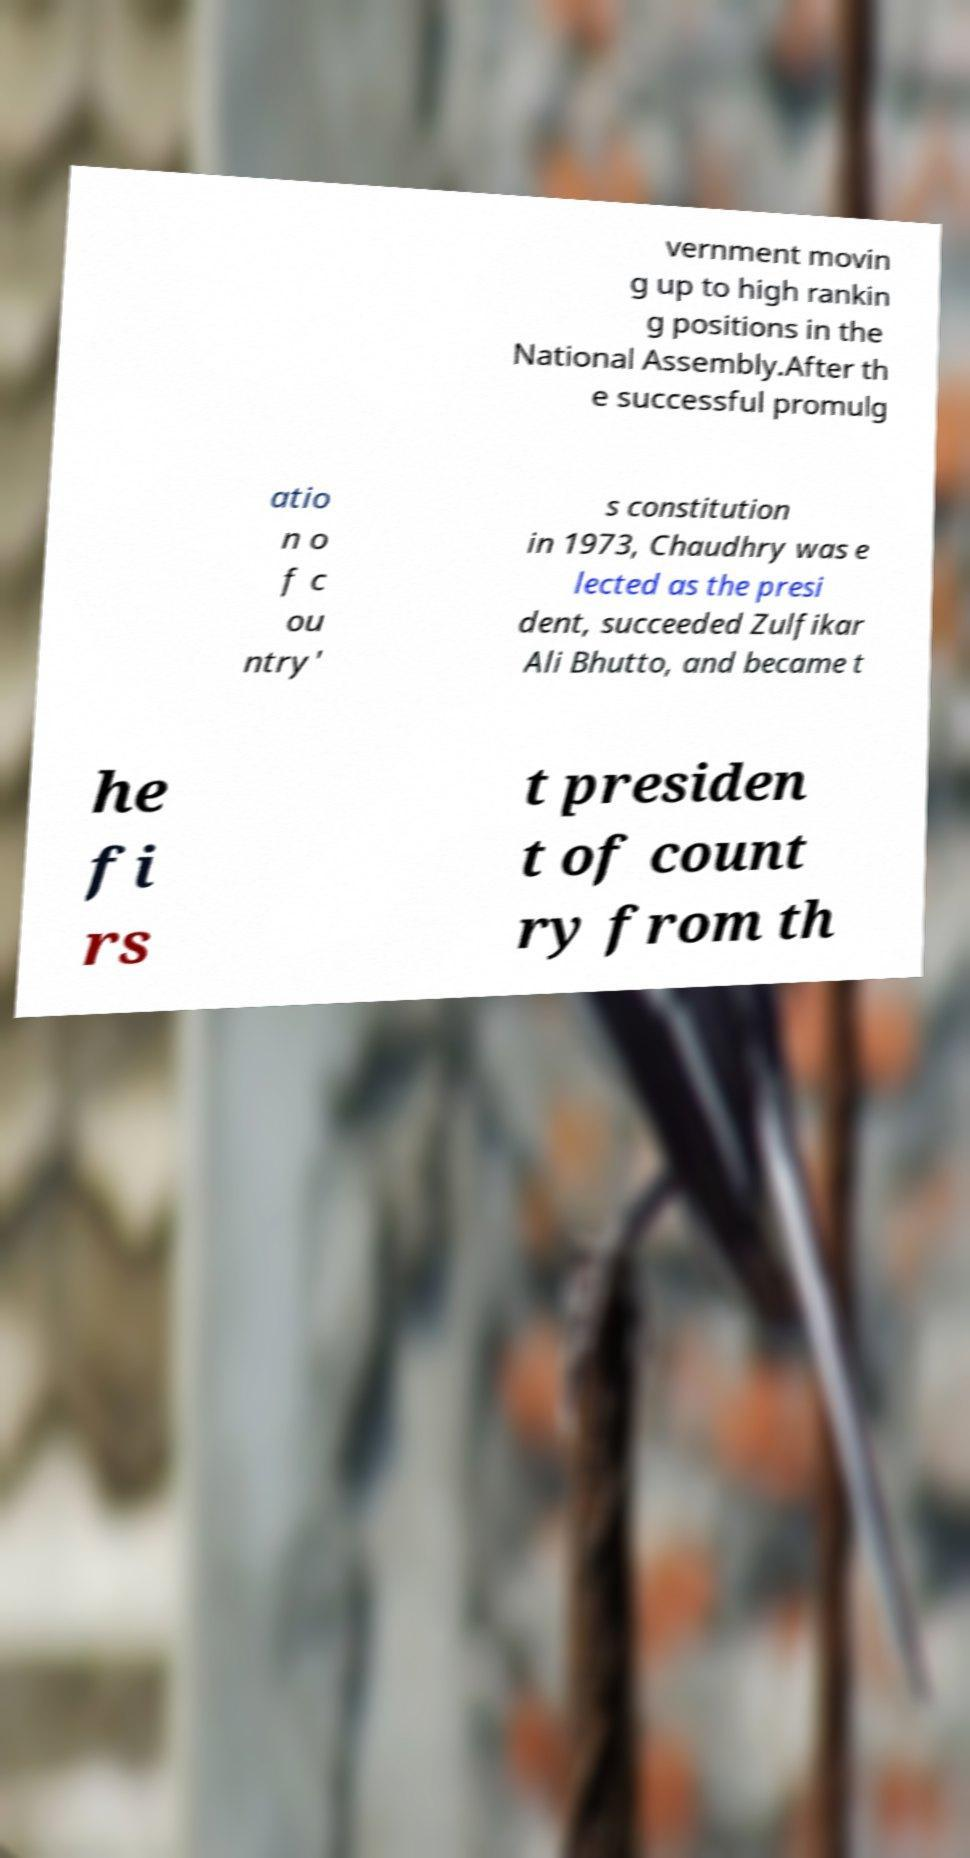Can you read and provide the text displayed in the image?This photo seems to have some interesting text. Can you extract and type it out for me? vernment movin g up to high rankin g positions in the National Assembly.After th e successful promulg atio n o f c ou ntry' s constitution in 1973, Chaudhry was e lected as the presi dent, succeeded Zulfikar Ali Bhutto, and became t he fi rs t presiden t of count ry from th 